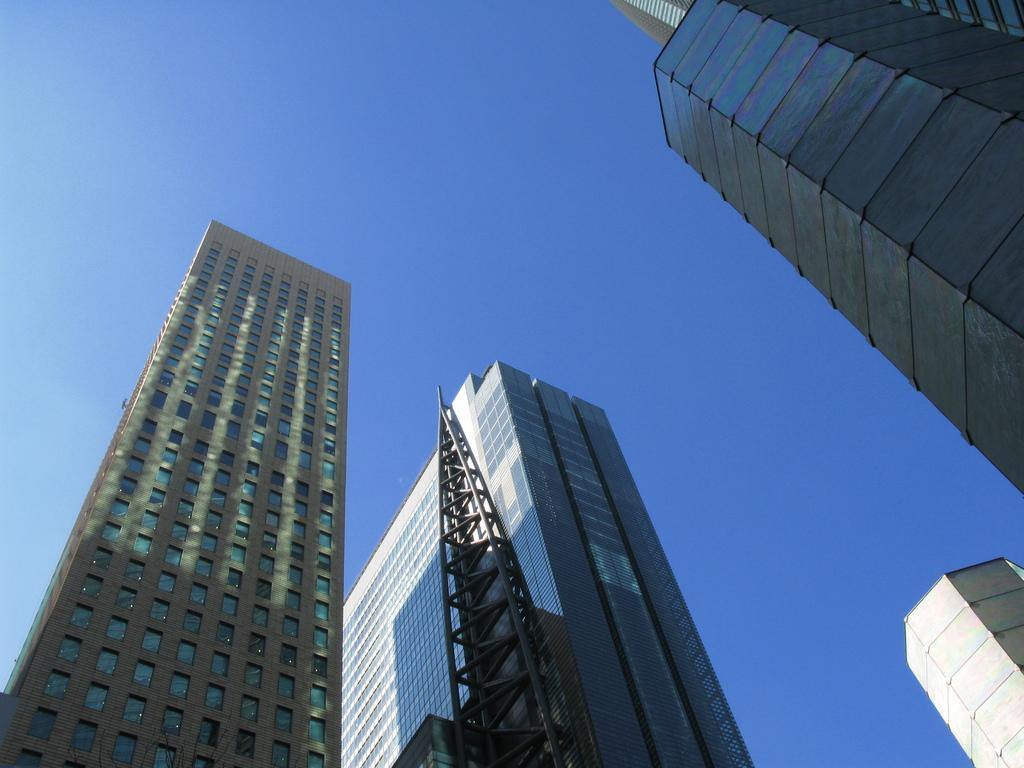Can you describe this image briefly? In this image we can see buildings. In the background there is sky. 